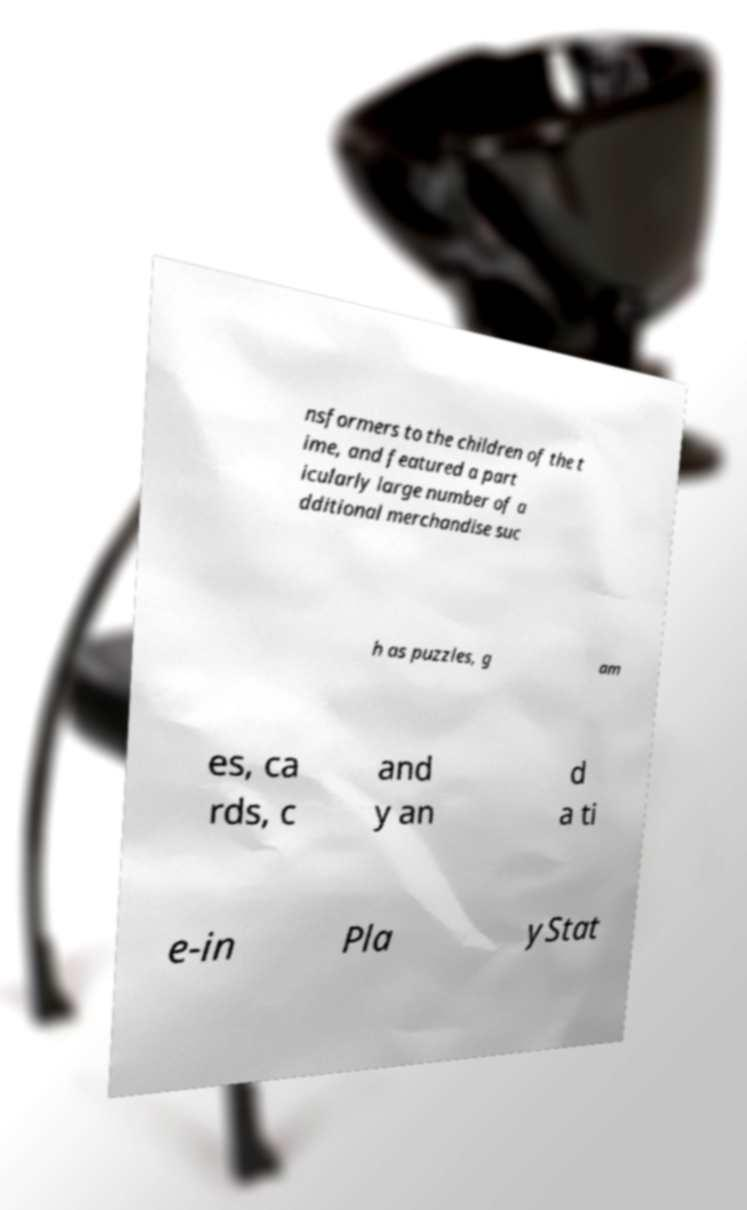Could you assist in decoding the text presented in this image and type it out clearly? nsformers to the children of the t ime, and featured a part icularly large number of a dditional merchandise suc h as puzzles, g am es, ca rds, c and y an d a ti e-in Pla yStat 